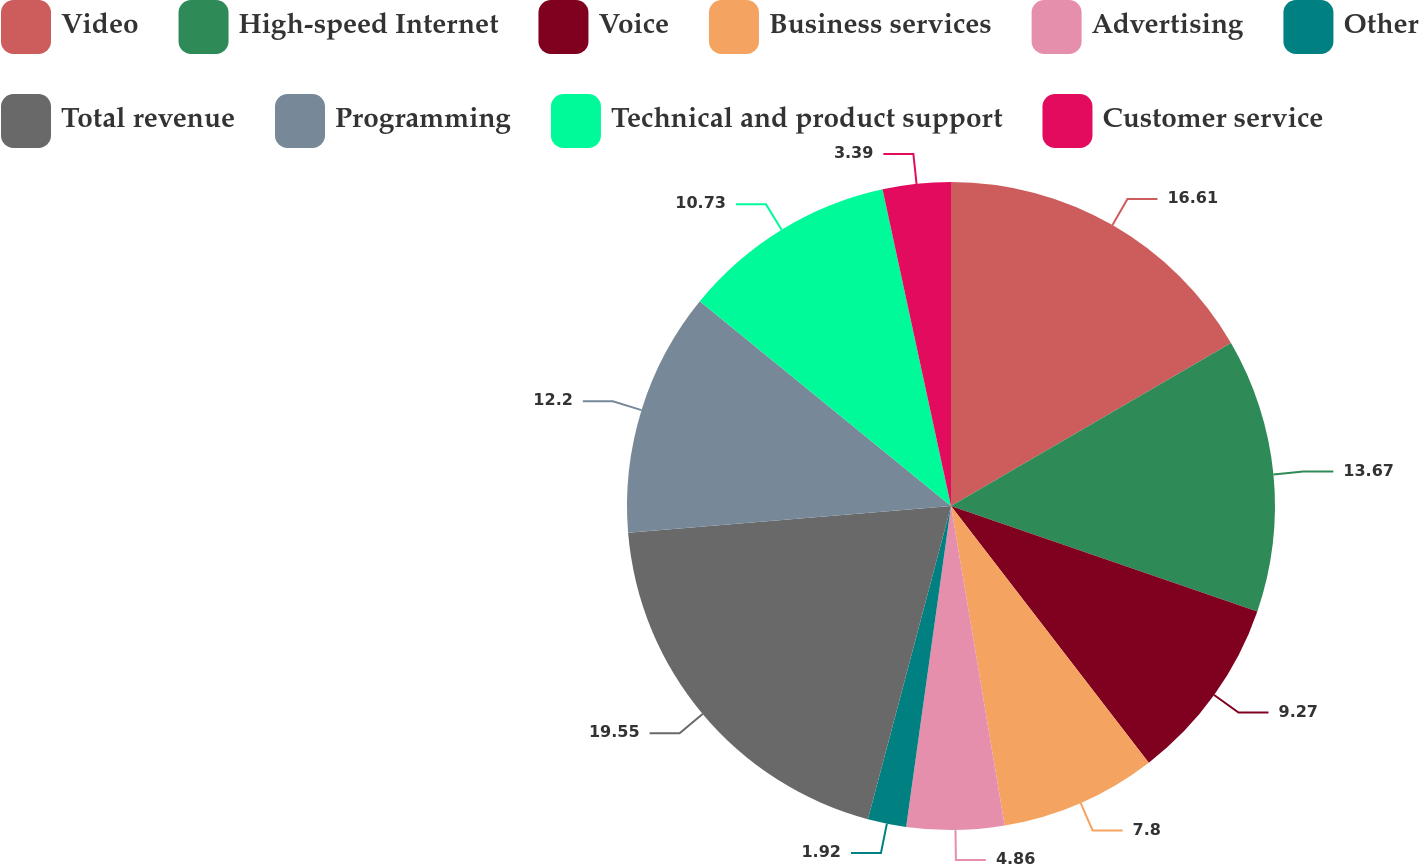<chart> <loc_0><loc_0><loc_500><loc_500><pie_chart><fcel>Video<fcel>High-speed Internet<fcel>Voice<fcel>Business services<fcel>Advertising<fcel>Other<fcel>Total revenue<fcel>Programming<fcel>Technical and product support<fcel>Customer service<nl><fcel>16.61%<fcel>13.67%<fcel>9.27%<fcel>7.8%<fcel>4.86%<fcel>1.92%<fcel>19.55%<fcel>12.2%<fcel>10.73%<fcel>3.39%<nl></chart> 